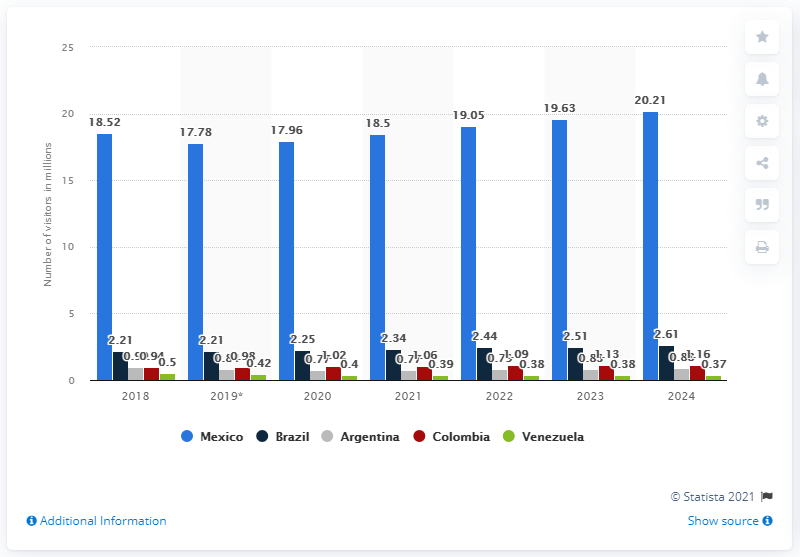Identify some key points in this picture. In 2018, 18,500 travelers arrived in the United States from Mexico. By the year 2024, it is projected that the number of travelers visiting the United States will increase to 20.21 million. 